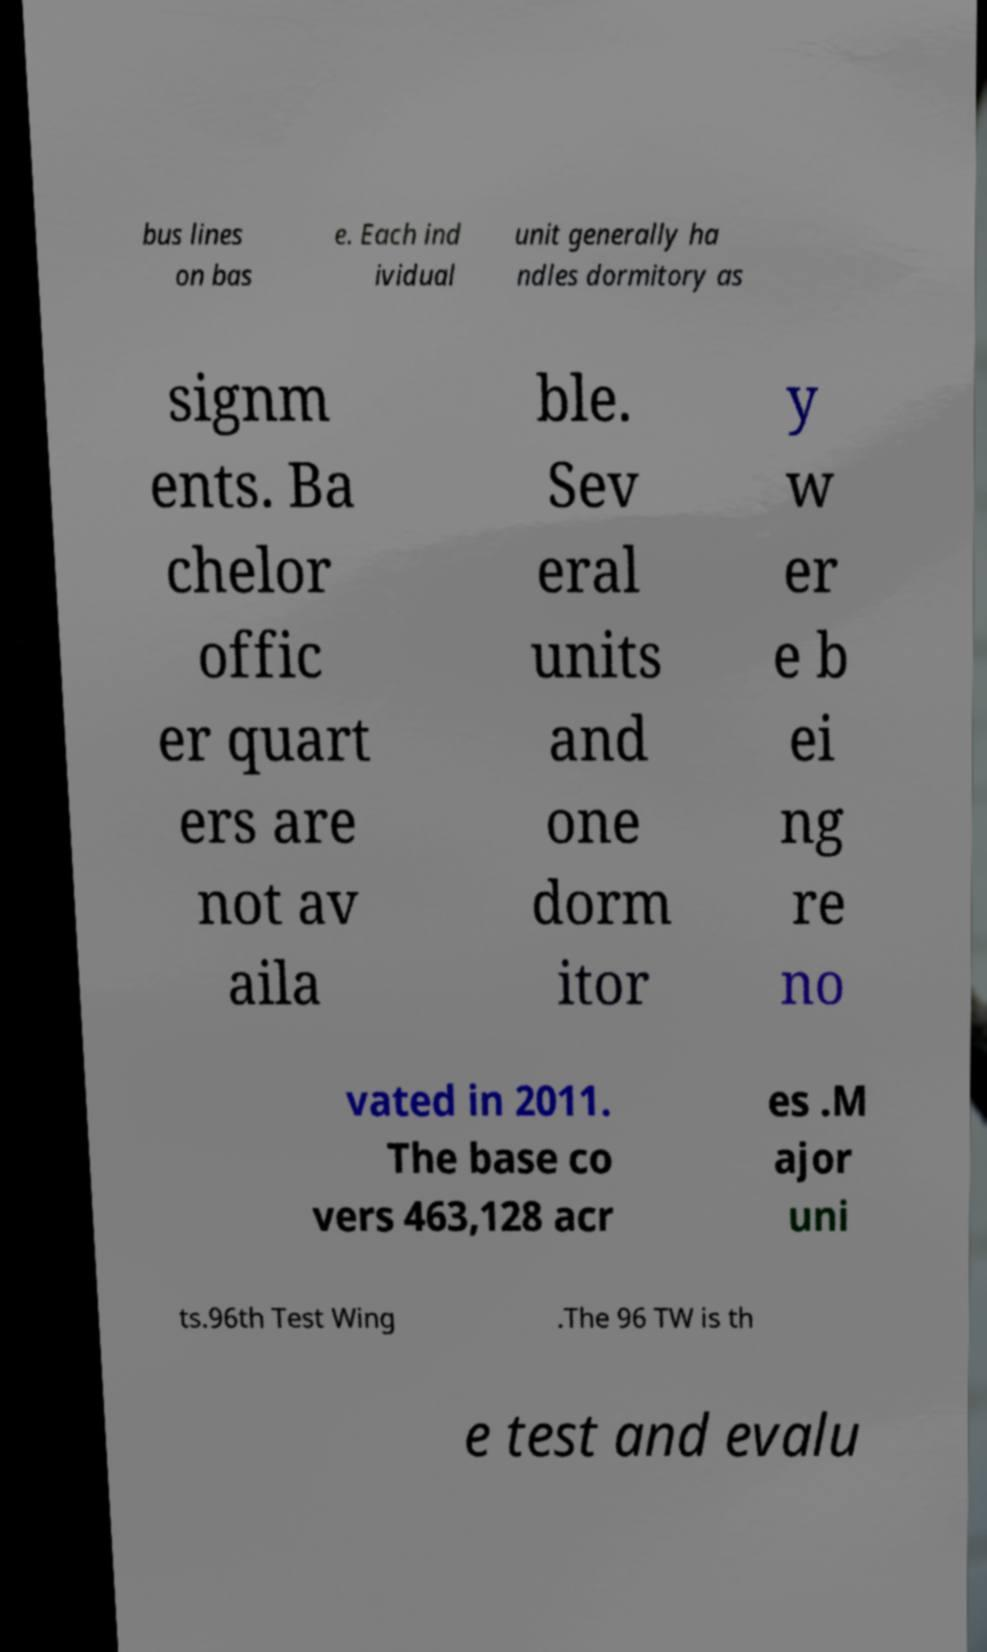There's text embedded in this image that I need extracted. Can you transcribe it verbatim? bus lines on bas e. Each ind ividual unit generally ha ndles dormitory as signm ents. Ba chelor offic er quart ers are not av aila ble. Sev eral units and one dorm itor y w er e b ei ng re no vated in 2011. The base co vers 463,128 acr es .M ajor uni ts.96th Test Wing .The 96 TW is th e test and evalu 